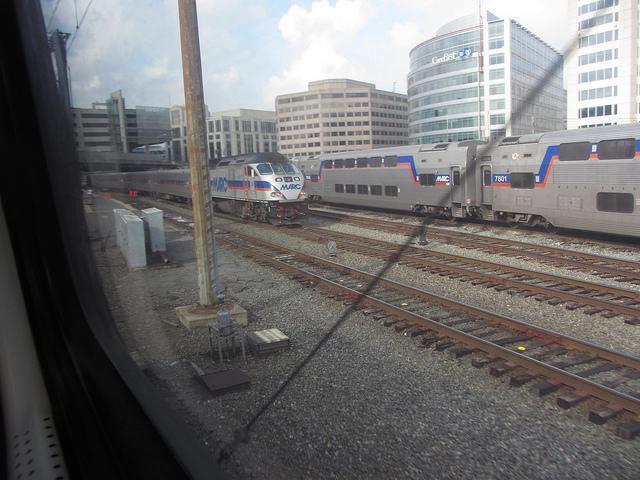How many trains can be seen?
Give a very brief answer. 2. How many ski lifts are to the right of the man in the yellow coat?
Give a very brief answer. 0. 